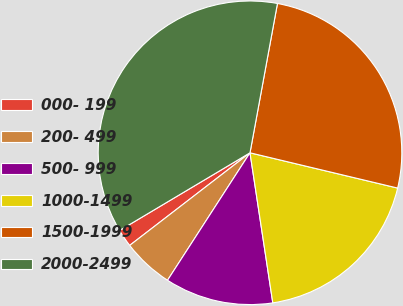Convert chart. <chart><loc_0><loc_0><loc_500><loc_500><pie_chart><fcel>000- 199<fcel>200- 499<fcel>500- 999<fcel>1000-1499<fcel>1500-1999<fcel>2000-2499<nl><fcel>1.89%<fcel>5.42%<fcel>11.54%<fcel>18.87%<fcel>25.84%<fcel>36.45%<nl></chart> 